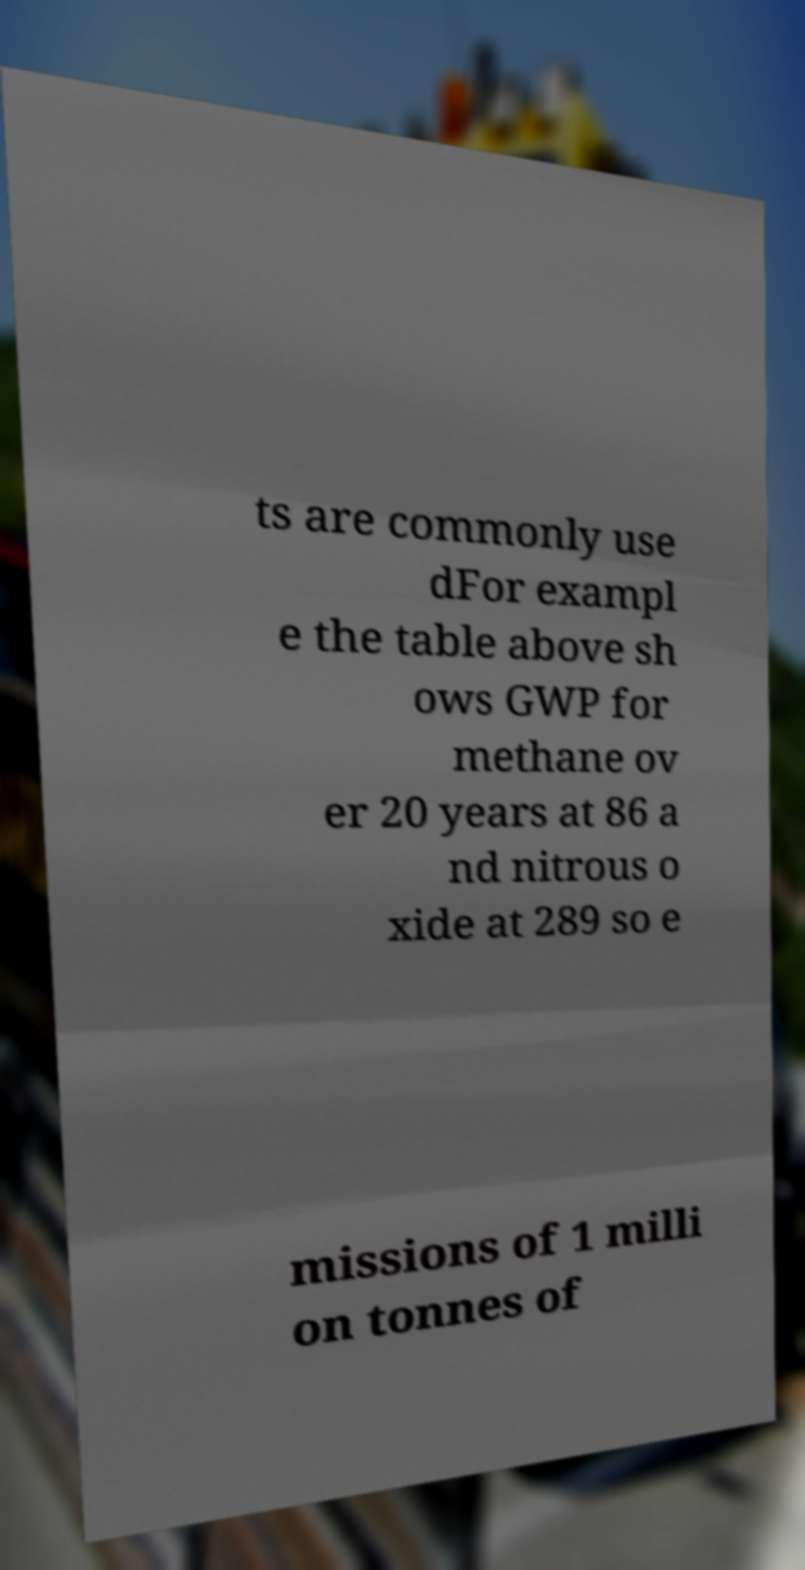For documentation purposes, I need the text within this image transcribed. Could you provide that? ts are commonly use dFor exampl e the table above sh ows GWP for methane ov er 20 years at 86 a nd nitrous o xide at 289 so e missions of 1 milli on tonnes of 